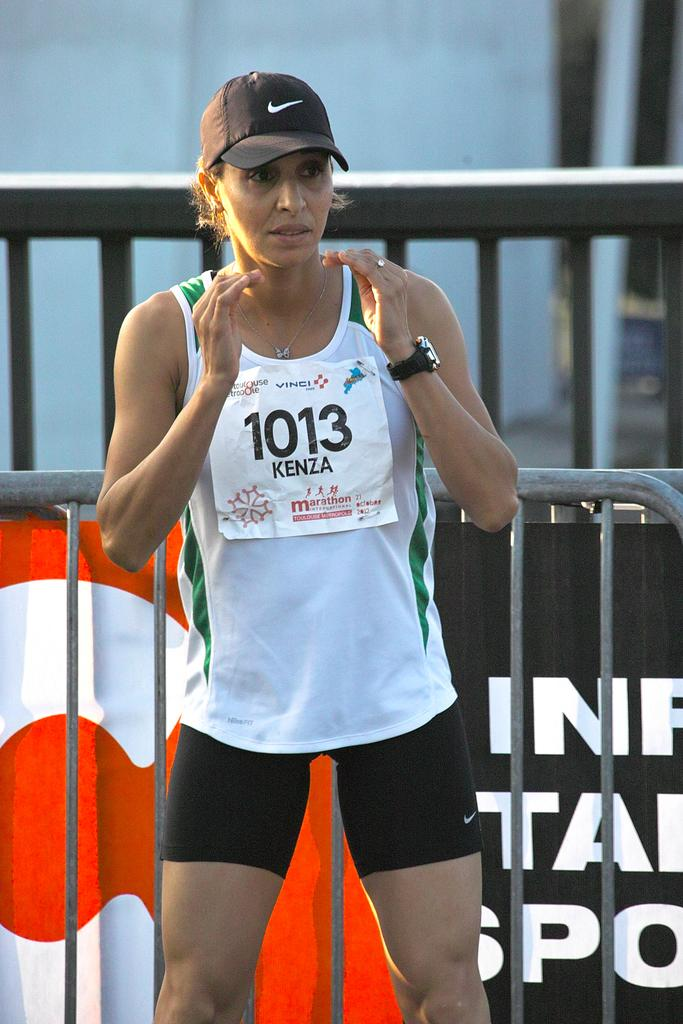<image>
Present a compact description of the photo's key features. A woman wearing a sign saying 1013 Kenza stands in front of a barrier. 